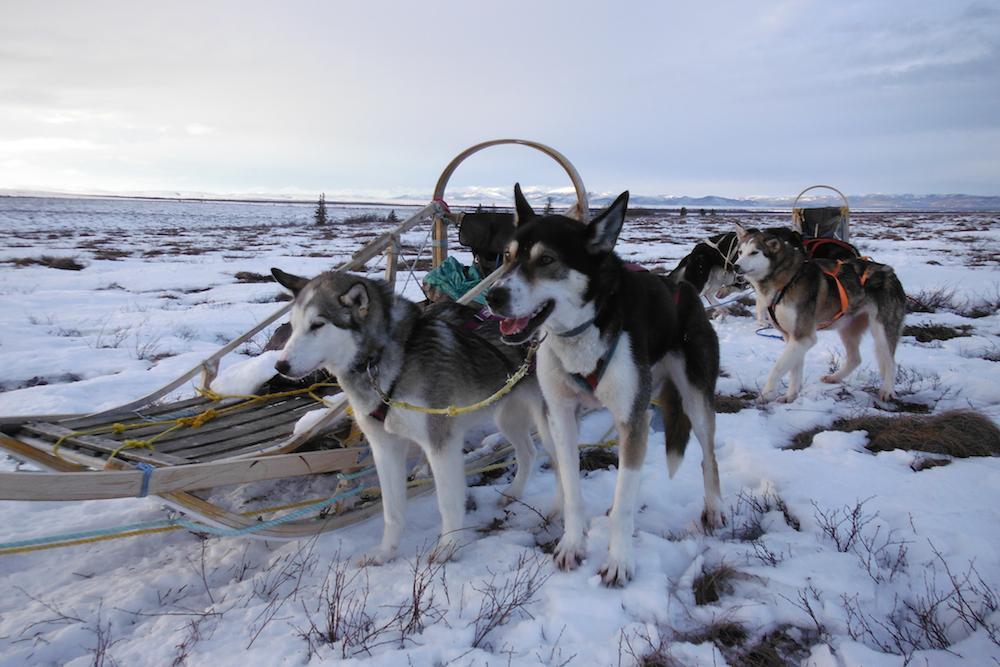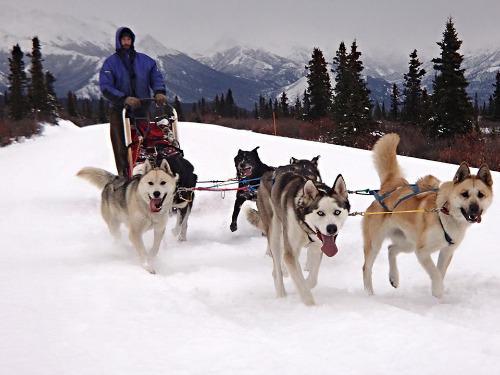The first image is the image on the left, the second image is the image on the right. Given the left and right images, does the statement "Both images in the pair show sled dogs attached to a sled." hold true? Answer yes or no. Yes. 